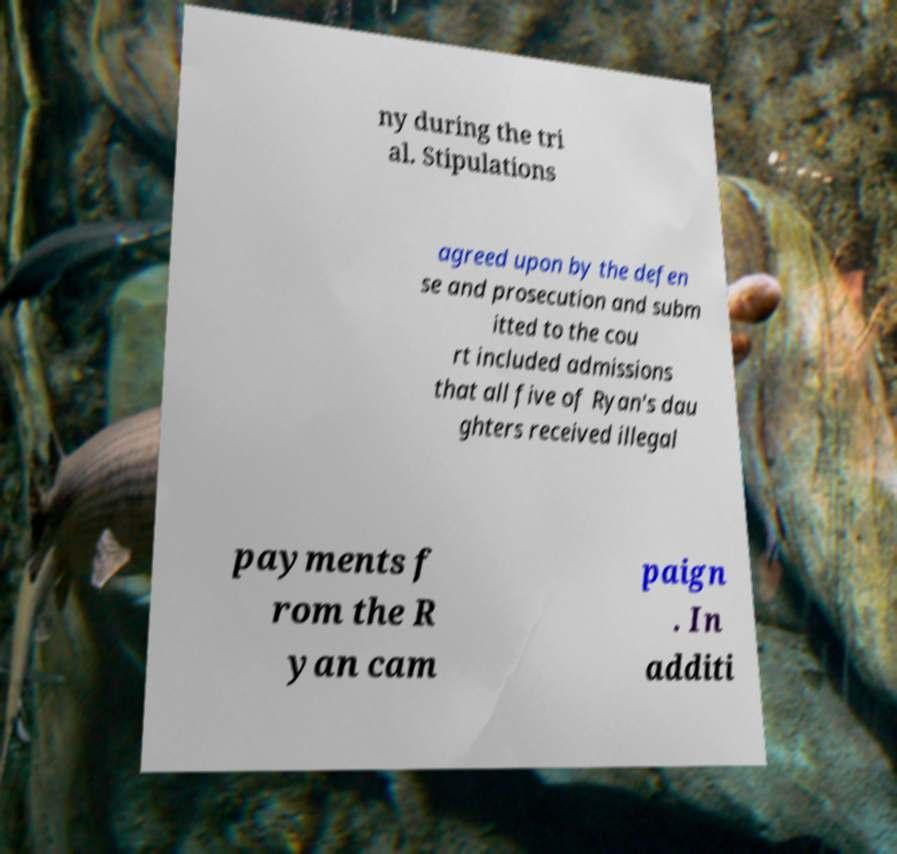There's text embedded in this image that I need extracted. Can you transcribe it verbatim? ny during the tri al. Stipulations agreed upon by the defen se and prosecution and subm itted to the cou rt included admissions that all five of Ryan's dau ghters received illegal payments f rom the R yan cam paign . In additi 